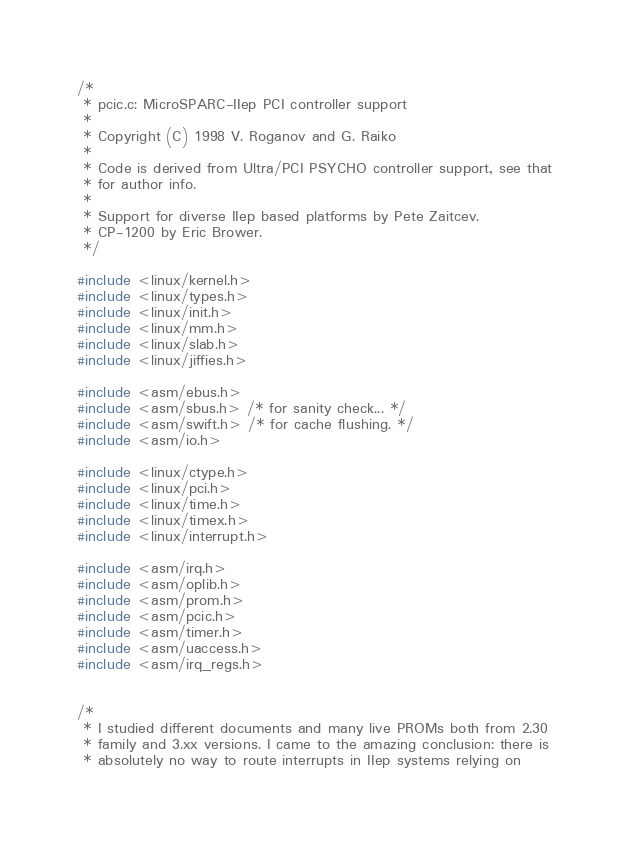<code> <loc_0><loc_0><loc_500><loc_500><_C_>/*
 * pcic.c: MicroSPARC-IIep PCI controller support
 *
 * Copyright (C) 1998 V. Roganov and G. Raiko
 *
 * Code is derived from Ultra/PCI PSYCHO controller support, see that
 * for author info.
 *
 * Support for diverse IIep based platforms by Pete Zaitcev.
 * CP-1200 by Eric Brower.
 */

#include <linux/kernel.h>
#include <linux/types.h>
#include <linux/init.h>
#include <linux/mm.h>
#include <linux/slab.h>
#include <linux/jiffies.h>

#include <asm/ebus.h>
#include <asm/sbus.h> /* for sanity check... */
#include <asm/swift.h> /* for cache flushing. */
#include <asm/io.h>

#include <linux/ctype.h>
#include <linux/pci.h>
#include <linux/time.h>
#include <linux/timex.h>
#include <linux/interrupt.h>

#include <asm/irq.h>
#include <asm/oplib.h>
#include <asm/prom.h>
#include <asm/pcic.h>
#include <asm/timer.h>
#include <asm/uaccess.h>
#include <asm/irq_regs.h>


/*
 * I studied different documents and many live PROMs both from 2.30
 * family and 3.xx versions. I came to the amazing conclusion: there is
 * absolutely no way to route interrupts in IIep systems relying on</code> 